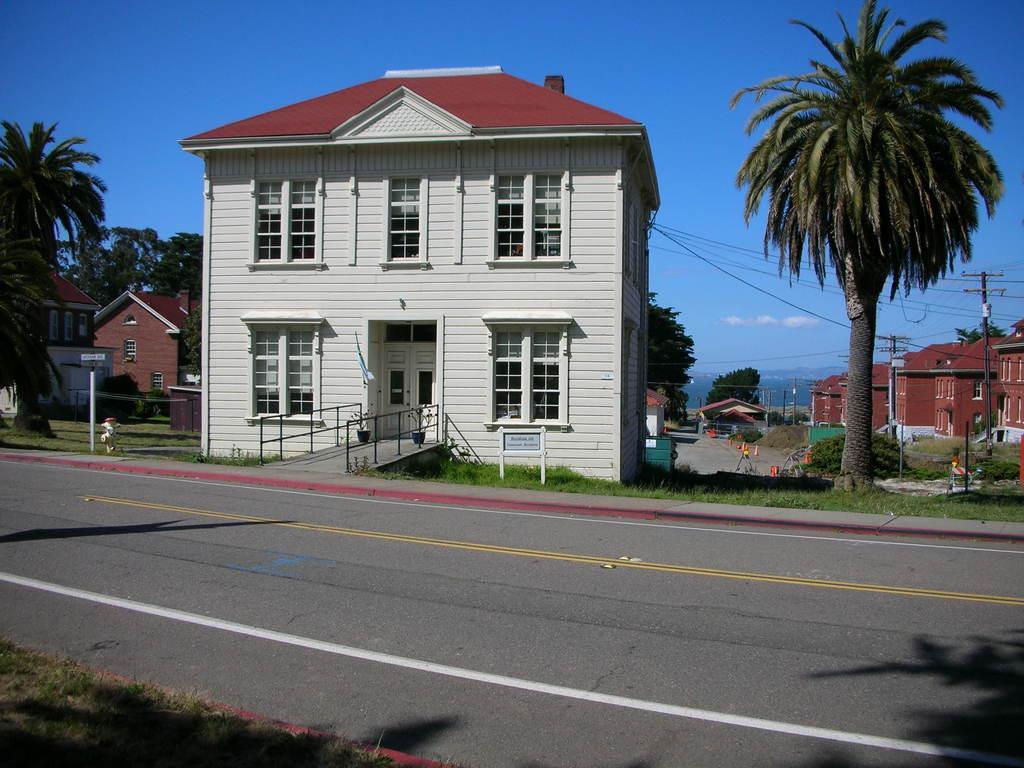In one or two sentences, can you explain what this image depicts? In this image, we can see a road in front of some houses and trees. There are poles on the right side of the image. There is a sign board on the left side of the image. In the background of the image, there is a sky. 